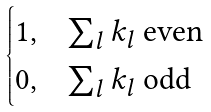Convert formula to latex. <formula><loc_0><loc_0><loc_500><loc_500>\begin{cases} 1 , & \text {$\sum_{l} k_{l}$ even} \\ 0 , & \text {$\sum_{l} k_{l}$ odd} \end{cases}</formula> 